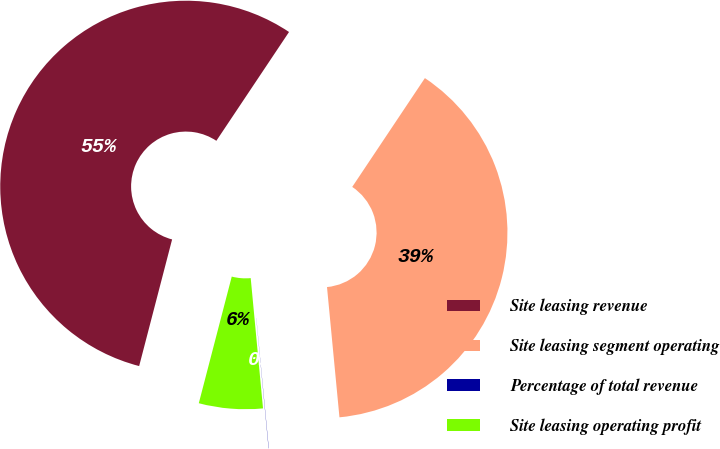Convert chart. <chart><loc_0><loc_0><loc_500><loc_500><pie_chart><fcel>Site leasing revenue<fcel>Site leasing segment operating<fcel>Percentage of total revenue<fcel>Site leasing operating profit<nl><fcel>55.32%<fcel>39.11%<fcel>0.02%<fcel>5.55%<nl></chart> 